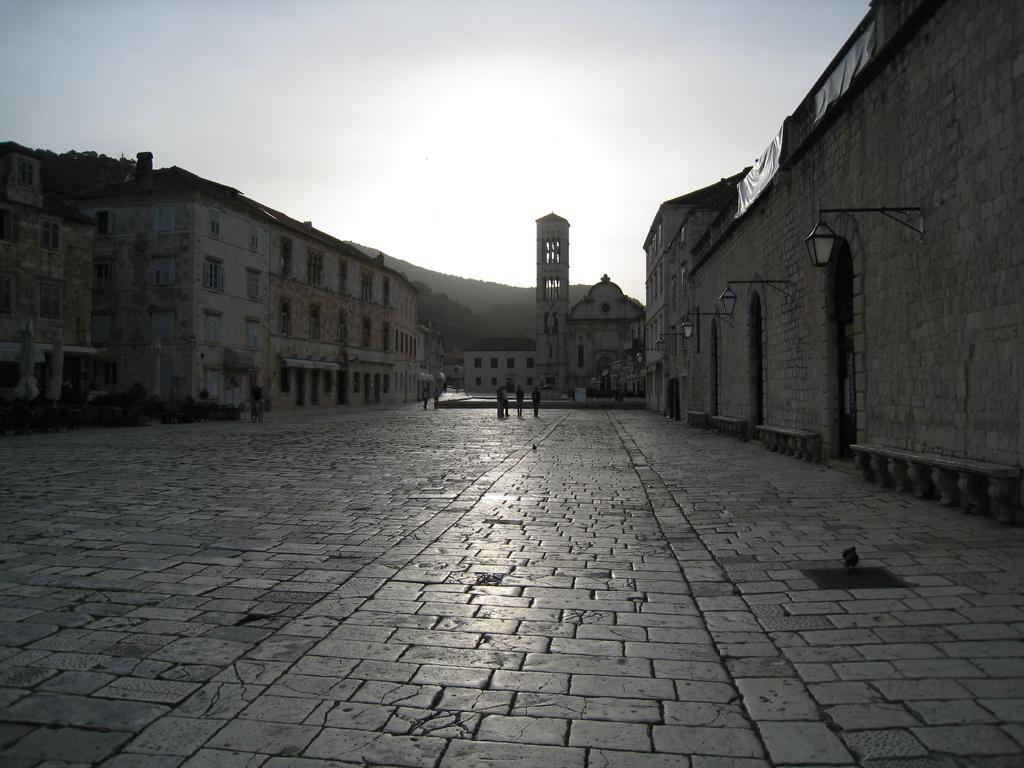What type of structures can be seen in the image? There are buildings in the image. What are the people in the image doing? People are walking in the image. What type of vegetation is present in the image? There are plants and trees visible in the image. What can be seen hanging on the wall in the image? There are lights hanging on the wall in the image. What is the weather like in the image? The sky is cloudy in the image. What type of pollution is visible in the image? There is no mention of pollution in the image, so it cannot be determined from the provided facts. What type of crime is taking place in the image? There is no mention of crime in the image, so it cannot be determined from the provided facts. 